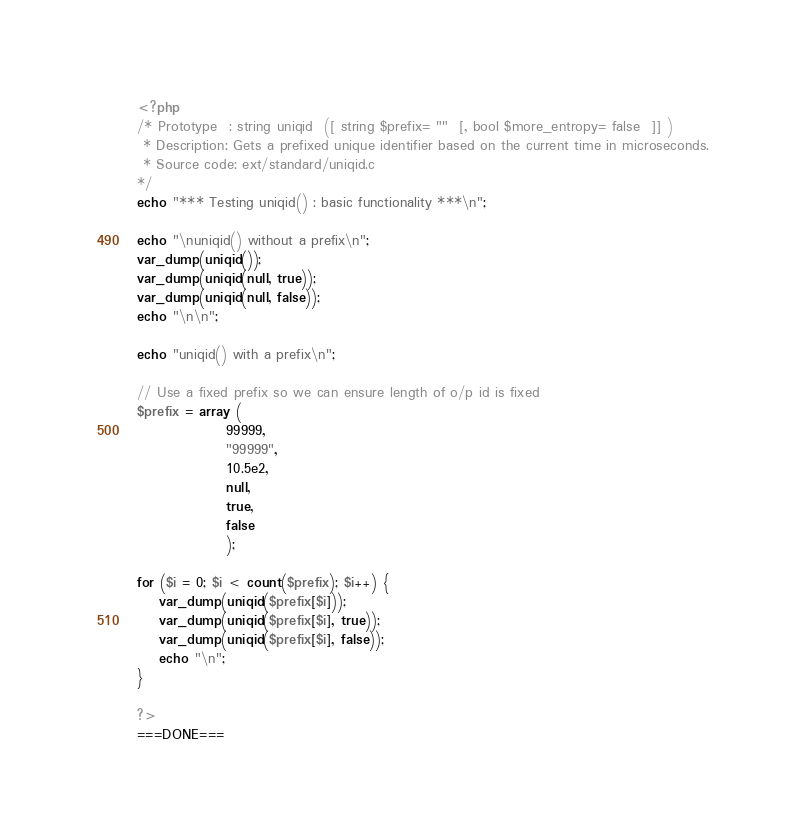Convert code to text. <code><loc_0><loc_0><loc_500><loc_500><_PHP_><?php
/* Prototype  : string uniqid  ([ string $prefix= ""  [, bool $more_entropy= false  ]] )
 * Description: Gets a prefixed unique identifier based on the current time in microseconds. 
 * Source code: ext/standard/uniqid.c
*/
echo "*** Testing uniqid() : basic functionality ***\n";

echo "\nuniqid() without a prefix\n";
var_dump(uniqid());
var_dump(uniqid(null, true));
var_dump(uniqid(null, false));
echo "\n\n";

echo "uniqid() with a prefix\n";

// Use a fixed prefix so we can ensure length of o/p id is fixed 
$prefix = array (
				99999,
				"99999",
				10.5e2,
				null,
				true,
				false				
				);

for ($i = 0; $i < count($prefix); $i++) {				
	var_dump(uniqid($prefix[$i]));
	var_dump(uniqid($prefix[$i], true));
	var_dump(uniqid($prefix[$i], false));
	echo "\n";
}	

?>
===DONE===
</code> 